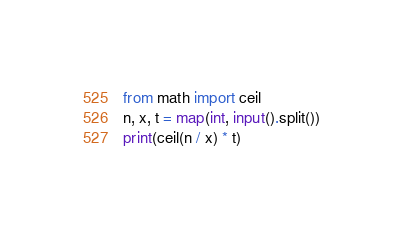Convert code to text. <code><loc_0><loc_0><loc_500><loc_500><_Python_>from math import ceil
n, x, t = map(int, input().split())
print(ceil(n / x) * t)</code> 